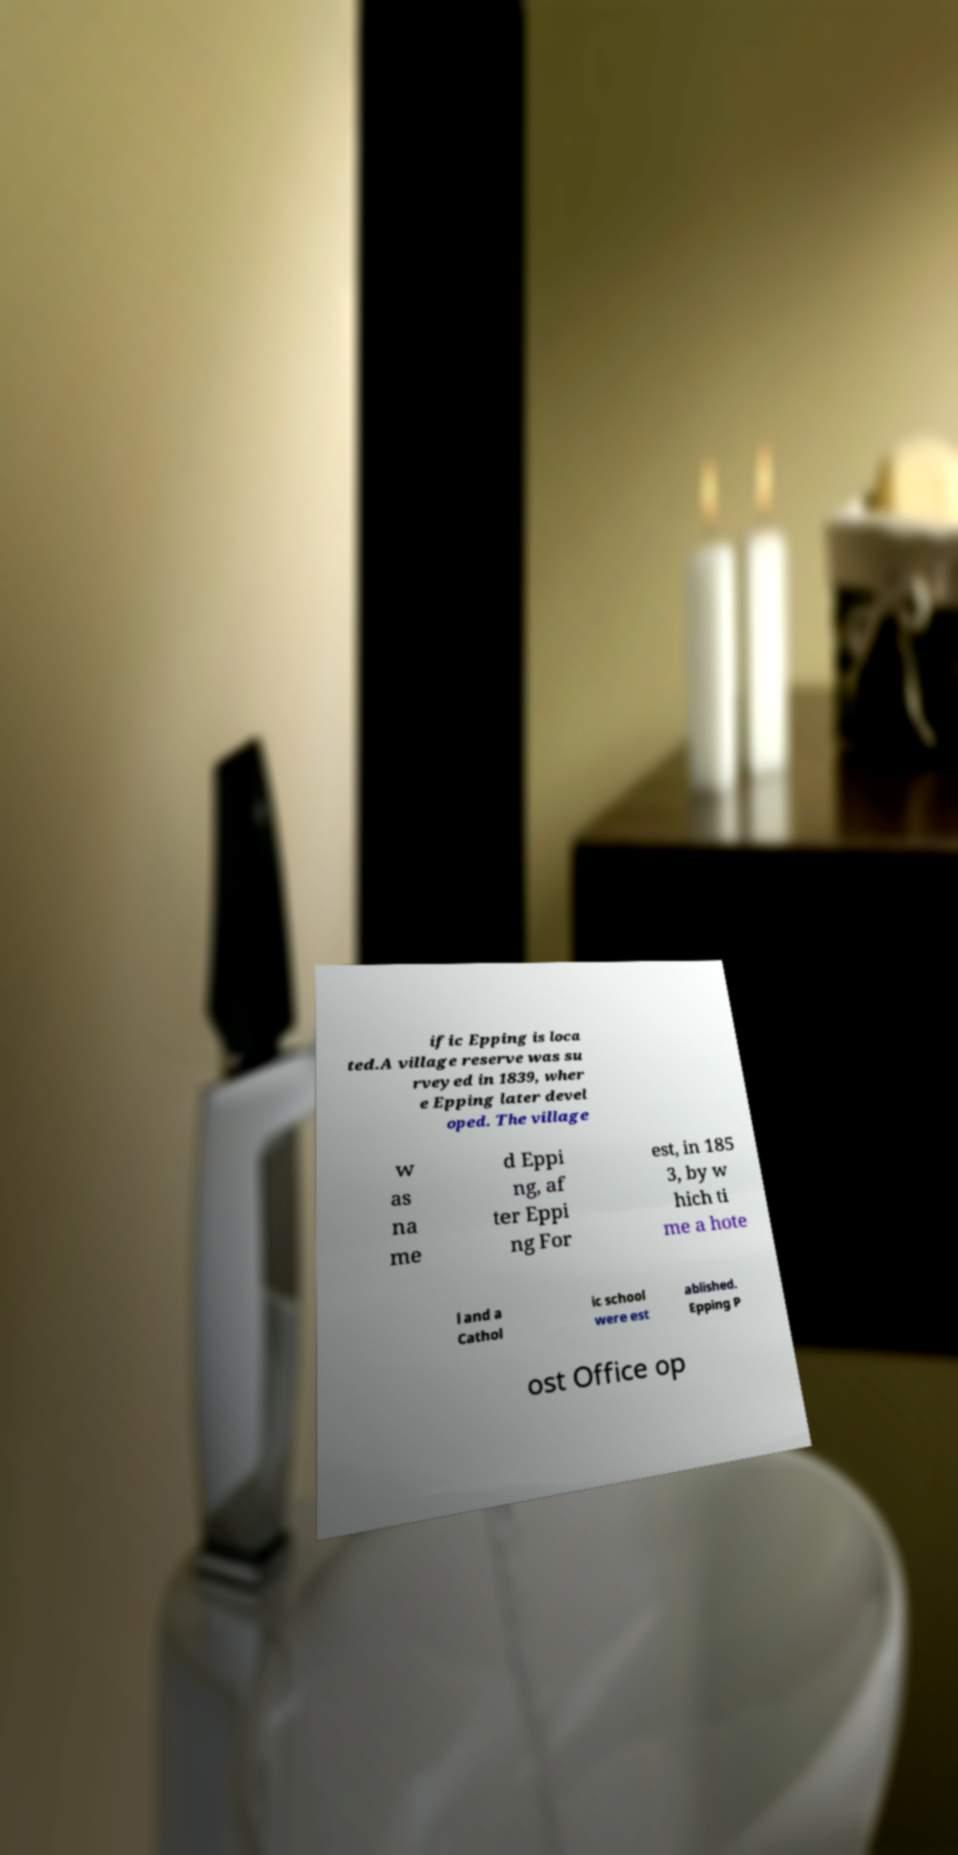Could you assist in decoding the text presented in this image and type it out clearly? ific Epping is loca ted.A village reserve was su rveyed in 1839, wher e Epping later devel oped. The village w as na me d Eppi ng, af ter Eppi ng For est, in 185 3, by w hich ti me a hote l and a Cathol ic school were est ablished. Epping P ost Office op 